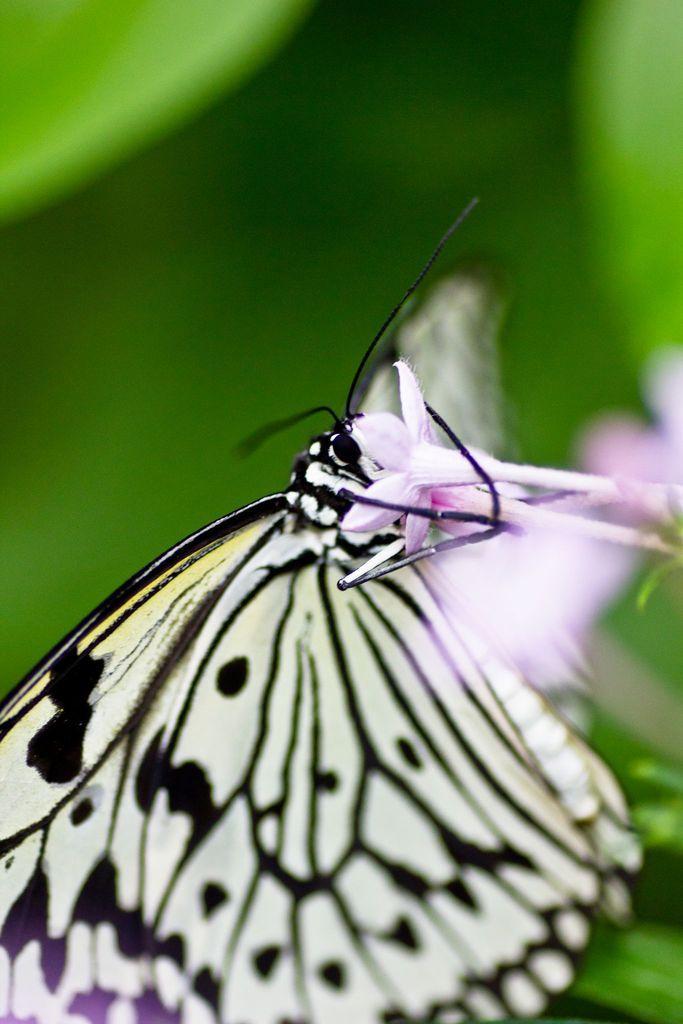Describe this image in one or two sentences. In this image I can see the butterfly to the pink color flower. I can see the butterfly is in black and yellow color. I can see there is a blurred background. 